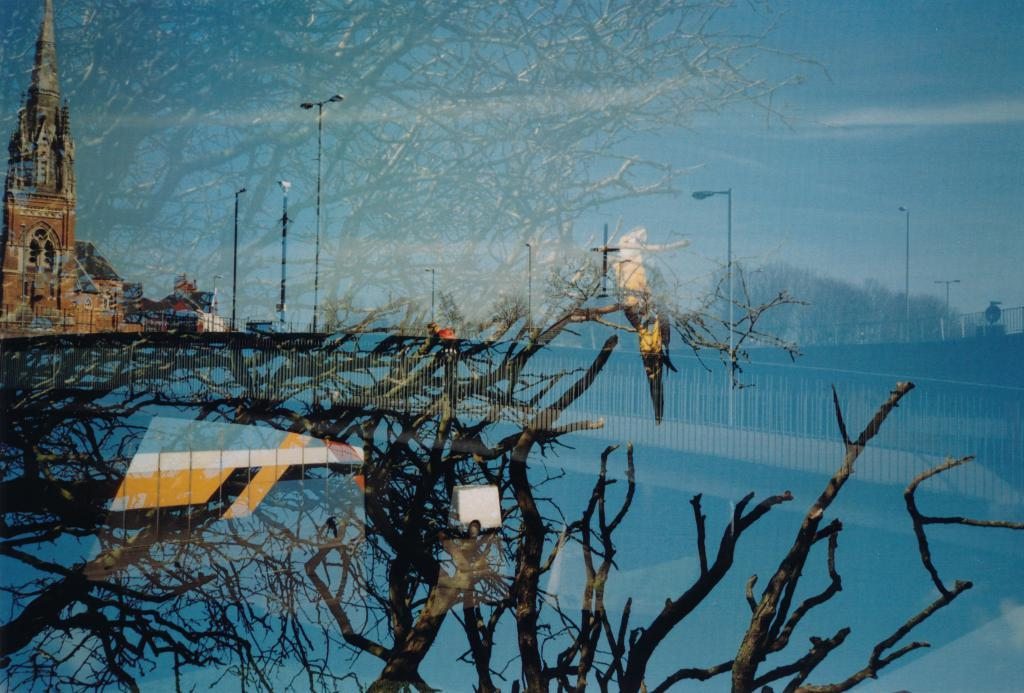What type of plant can be seen in the image? There is a tree in the image. What animal is present in the image? There is a bird in the image. What type of barrier can be seen in the image? There is a fence in the image. What type of lighting is present in the image? There are street lights in the image. What type of building can be seen in the image? There is a church in the image. Can you describe any other unspecified objects or features in the image? Unfortunately, the provided facts do not specify any other objects or features in the image. What type of mint can be seen growing on the fence in the image? There is no mint visible in the image, and the provided facts do not mention any mint. 